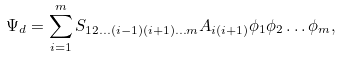<formula> <loc_0><loc_0><loc_500><loc_500>\Psi _ { d } = \sum _ { i = 1 } ^ { m } S _ { 1 2 \dots ( i - 1 ) ( i + 1 ) \dots m } A _ { i ( i + 1 ) } \phi _ { 1 } \phi _ { 2 } \dots \phi _ { m } ,</formula> 